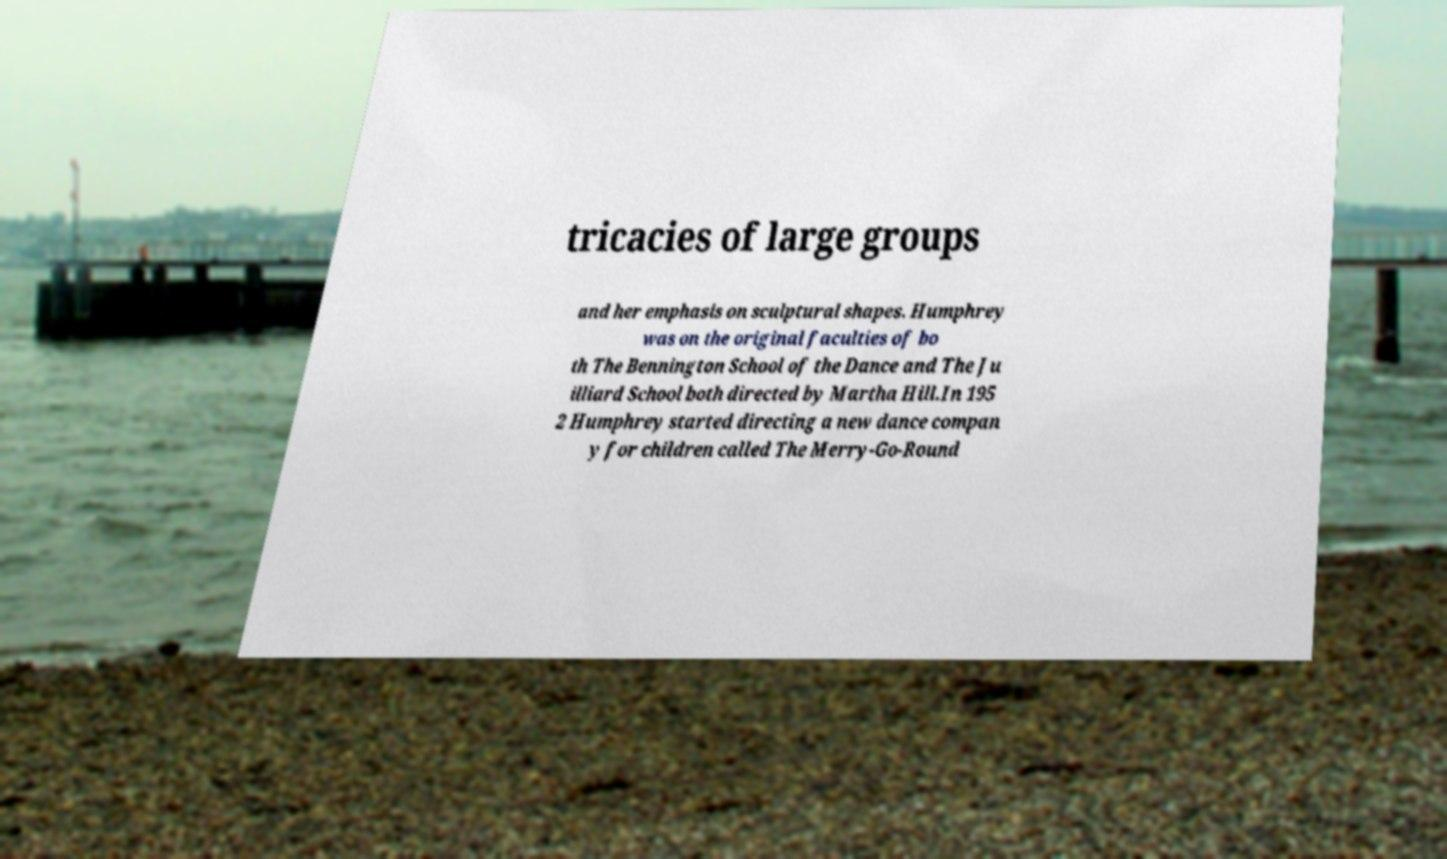There's text embedded in this image that I need extracted. Can you transcribe it verbatim? tricacies of large groups and her emphasis on sculptural shapes. Humphrey was on the original faculties of bo th The Bennington School of the Dance and The Ju illiard School both directed by Martha Hill.In 195 2 Humphrey started directing a new dance compan y for children called The Merry-Go-Round 